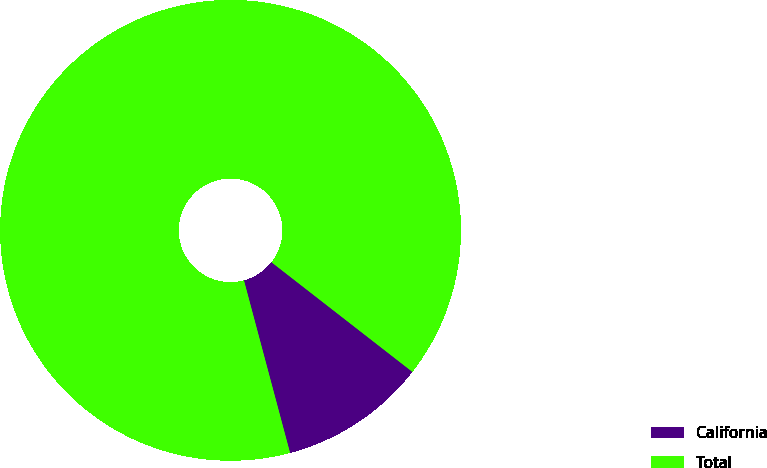Convert chart. <chart><loc_0><loc_0><loc_500><loc_500><pie_chart><fcel>California<fcel>Total<nl><fcel>10.32%<fcel>89.68%<nl></chart> 